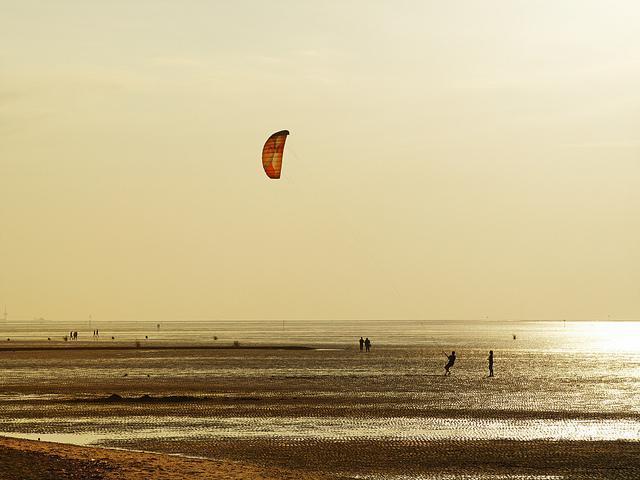How many people are holding onto the parachute line?
Give a very brief answer. 1. How many kites have a checkered pattern?
Give a very brief answer. 1. How many hot dogs are there in the picture?
Give a very brief answer. 0. 